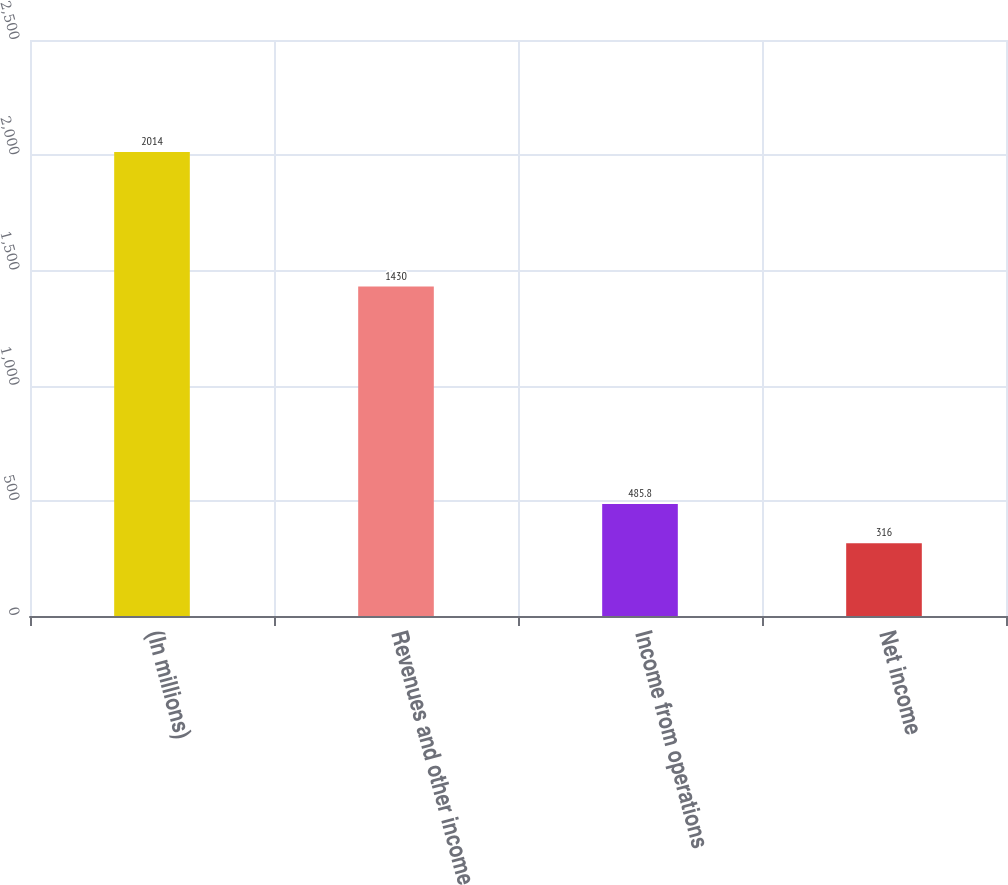Convert chart to OTSL. <chart><loc_0><loc_0><loc_500><loc_500><bar_chart><fcel>(In millions)<fcel>Revenues and other income<fcel>Income from operations<fcel>Net income<nl><fcel>2014<fcel>1430<fcel>485.8<fcel>316<nl></chart> 